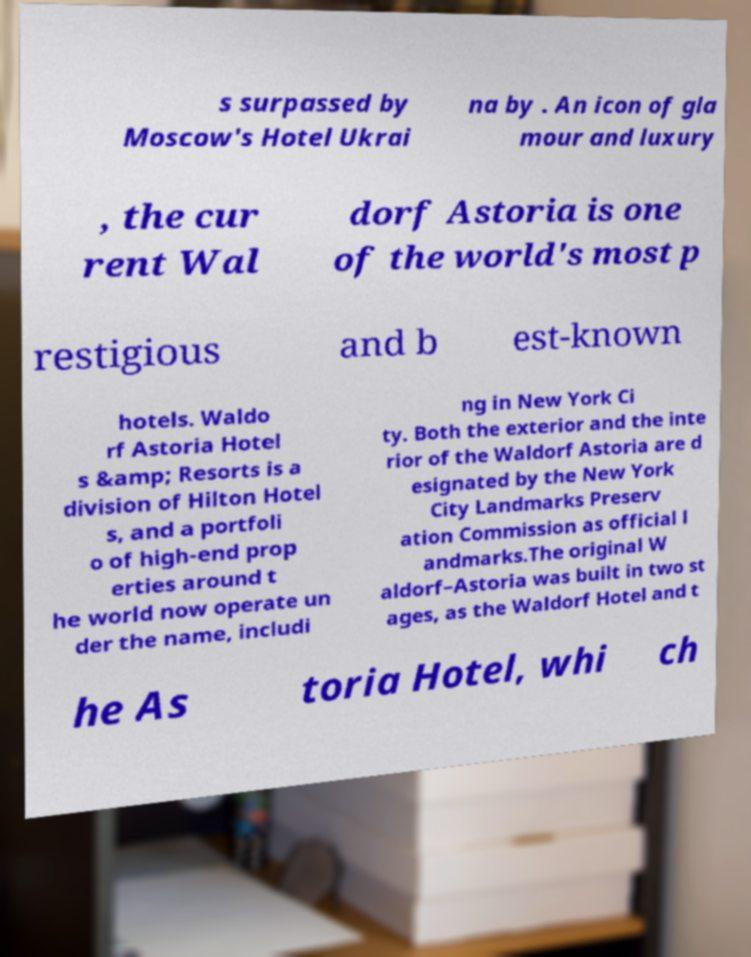Could you assist in decoding the text presented in this image and type it out clearly? s surpassed by Moscow's Hotel Ukrai na by . An icon of gla mour and luxury , the cur rent Wal dorf Astoria is one of the world's most p restigious and b est-known hotels. Waldo rf Astoria Hotel s &amp; Resorts is a division of Hilton Hotel s, and a portfoli o of high-end prop erties around t he world now operate un der the name, includi ng in New York Ci ty. Both the exterior and the inte rior of the Waldorf Astoria are d esignated by the New York City Landmarks Preserv ation Commission as official l andmarks.The original W aldorf–Astoria was built in two st ages, as the Waldorf Hotel and t he As toria Hotel, whi ch 